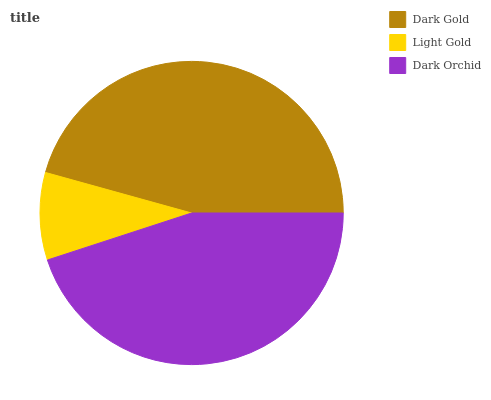Is Light Gold the minimum?
Answer yes or no. Yes. Is Dark Gold the maximum?
Answer yes or no. Yes. Is Dark Orchid the minimum?
Answer yes or no. No. Is Dark Orchid the maximum?
Answer yes or no. No. Is Dark Orchid greater than Light Gold?
Answer yes or no. Yes. Is Light Gold less than Dark Orchid?
Answer yes or no. Yes. Is Light Gold greater than Dark Orchid?
Answer yes or no. No. Is Dark Orchid less than Light Gold?
Answer yes or no. No. Is Dark Orchid the high median?
Answer yes or no. Yes. Is Dark Orchid the low median?
Answer yes or no. Yes. Is Light Gold the high median?
Answer yes or no. No. Is Light Gold the low median?
Answer yes or no. No. 